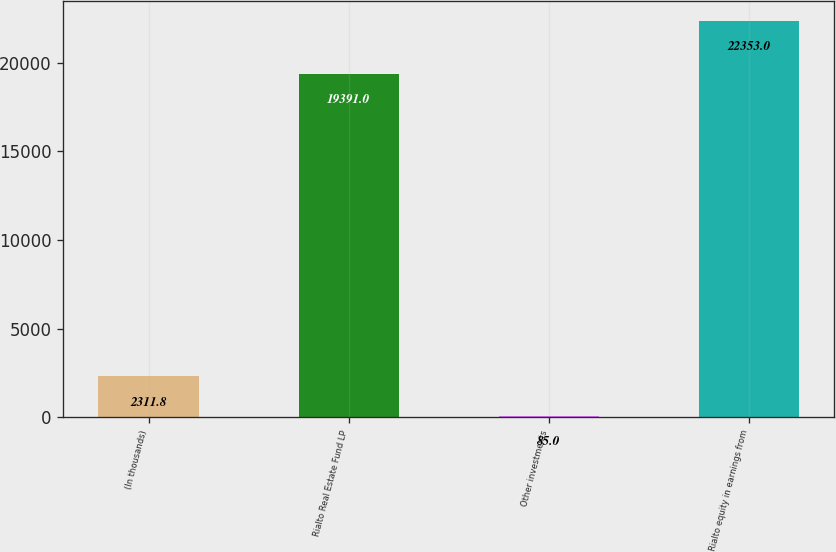<chart> <loc_0><loc_0><loc_500><loc_500><bar_chart><fcel>(In thousands)<fcel>Rialto Real Estate Fund LP<fcel>Other investments<fcel>Rialto equity in earnings from<nl><fcel>2311.8<fcel>19391<fcel>85<fcel>22353<nl></chart> 